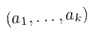Convert formula to latex. <formula><loc_0><loc_0><loc_500><loc_500>( a _ { 1 } , \dots , a _ { k } )</formula> 